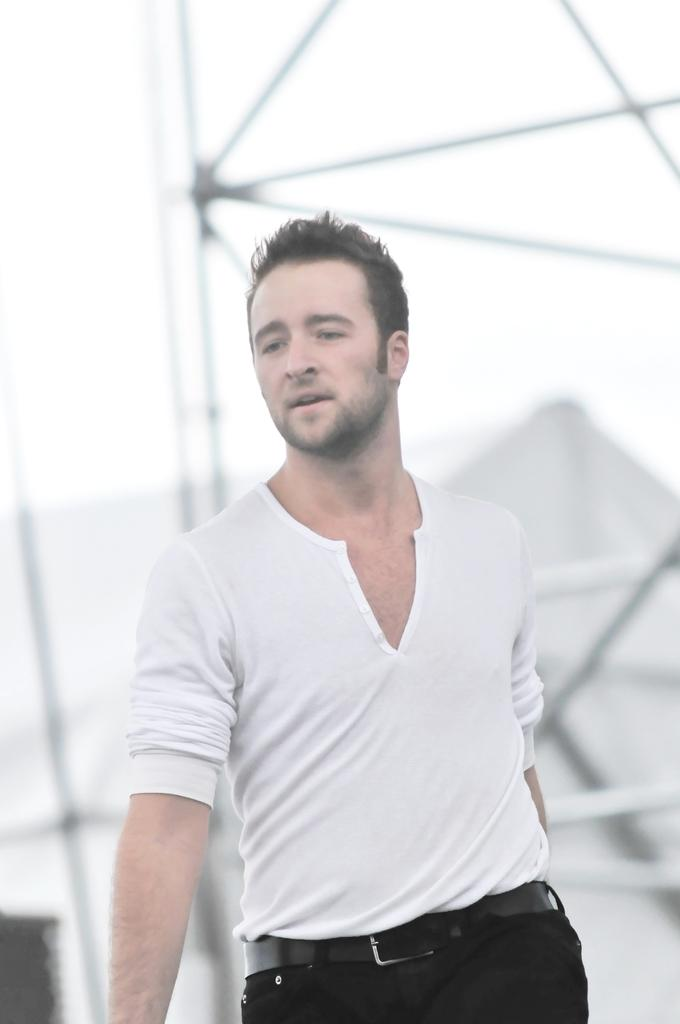Who is the main subject in the image? There is a man standing in the center of the image. What can be seen in the background of the image? There are towers and houses in the background of the image. How many cattle are present in the image? There are no cattle present in the image. 